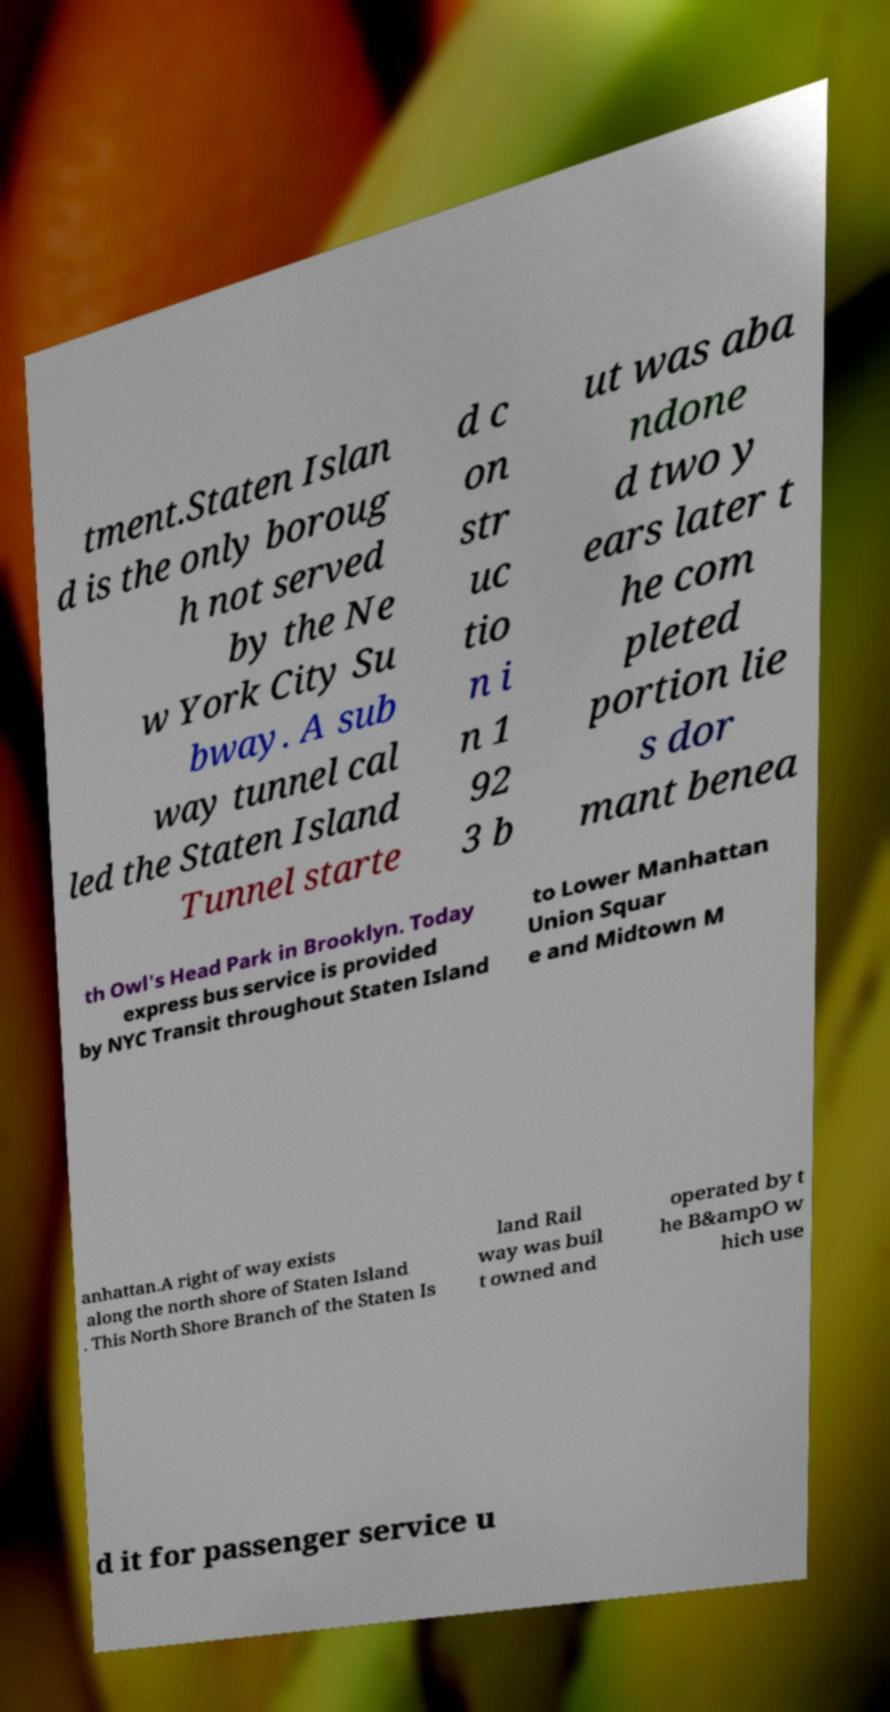For documentation purposes, I need the text within this image transcribed. Could you provide that? tment.Staten Islan d is the only boroug h not served by the Ne w York City Su bway. A sub way tunnel cal led the Staten Island Tunnel starte d c on str uc tio n i n 1 92 3 b ut was aba ndone d two y ears later t he com pleted portion lie s dor mant benea th Owl's Head Park in Brooklyn. Today express bus service is provided by NYC Transit throughout Staten Island to Lower Manhattan Union Squar e and Midtown M anhattan.A right of way exists along the north shore of Staten Island . This North Shore Branch of the Staten Is land Rail way was buil t owned and operated by t he B&ampO w hich use d it for passenger service u 